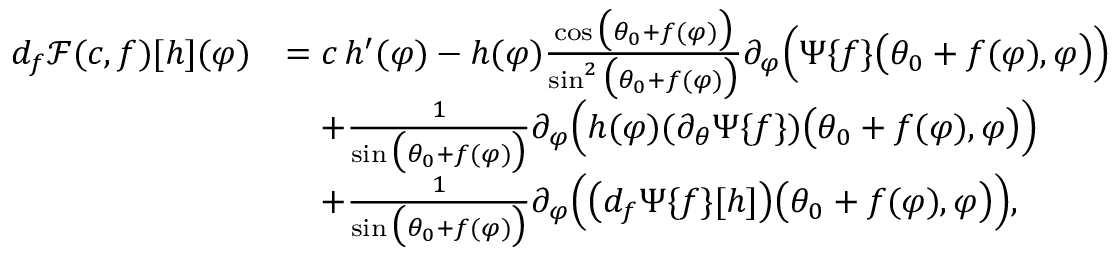Convert formula to latex. <formula><loc_0><loc_0><loc_500><loc_500>\begin{array} { r l } { d _ { f } \ m a t h s c r { F } ( c , f ) [ h ] ( \varphi ) } & { = c \, h ^ { \prime } ( \varphi ) - h ( \varphi ) \frac { \cos \left ( \theta _ { 0 } + f ( \varphi ) \right ) } { \sin ^ { 2 } \left ( \theta _ { 0 } + f ( \varphi ) \right ) } \partial _ { \varphi } \left ( \Psi \{ f \} \left ( \theta _ { 0 } + f ( \varphi ) , \varphi \right ) \right ) } \\ & { \quad + \frac { 1 } { \sin \left ( \theta _ { 0 } + f ( \varphi ) \right ) } \partial _ { \varphi } \left ( h ( \varphi ) ( \partial _ { \theta } \Psi \{ f \} ) \left ( \theta _ { 0 } + f ( \varphi ) , \varphi \right ) \right ) } \\ & { \quad + \frac { 1 } { \sin \left ( \theta _ { 0 } + f ( \varphi ) \right ) } \partial _ { \varphi } \left ( \left ( d _ { f } \Psi \{ f \} [ h ] \right ) \left ( \theta _ { 0 } + f ( \varphi ) , \varphi \right ) \right ) , } \end{array}</formula> 